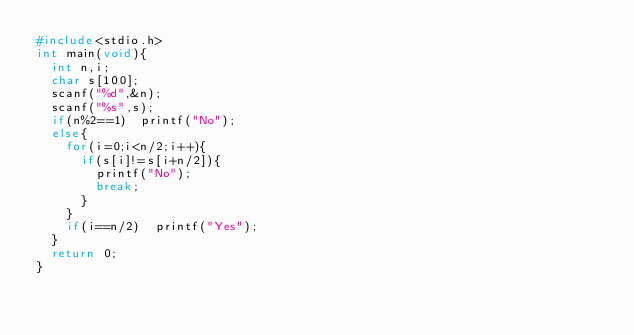Convert code to text. <code><loc_0><loc_0><loc_500><loc_500><_C_>#include<stdio.h>
int main(void){
  int n,i;
  char s[100];
  scanf("%d",&n);
  scanf("%s",s);
  if(n%2==1)  printf("No");
  else{
    for(i=0;i<n/2;i++){
      if(s[i]!=s[i+n/2]){
        printf("No");
        break;
      }
    }
    if(i==n/2)  printf("Yes");
  }
  return 0;
}</code> 